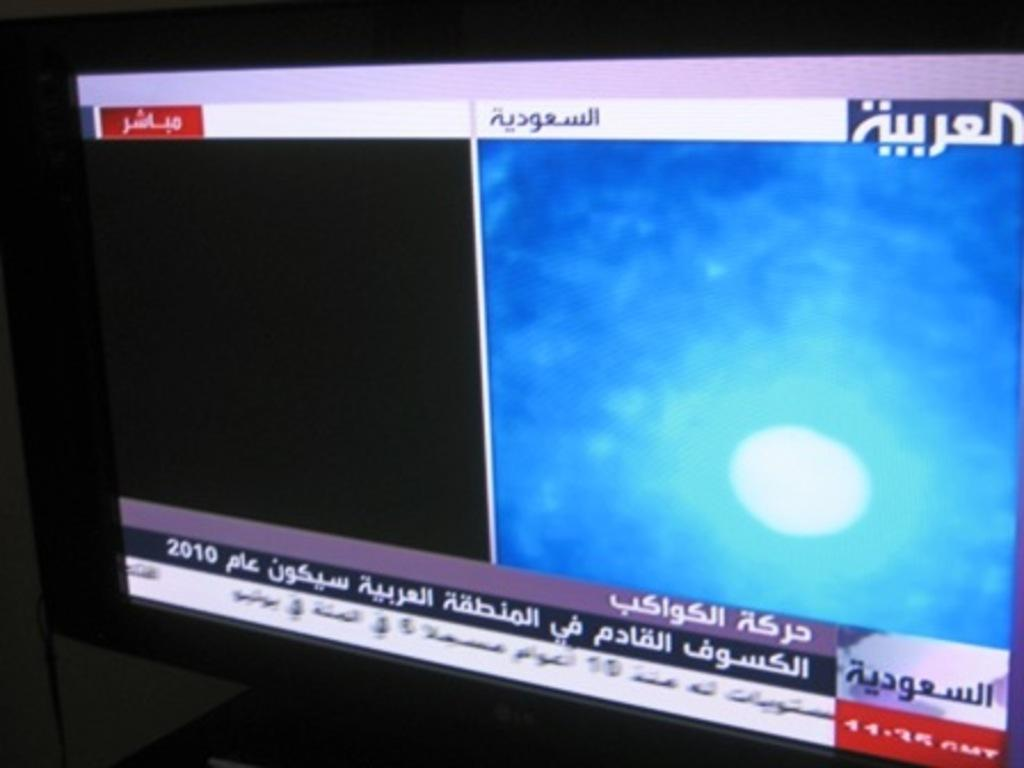<image>
Render a clear and concise summary of the photo. A television display shows the news in Arabic. 